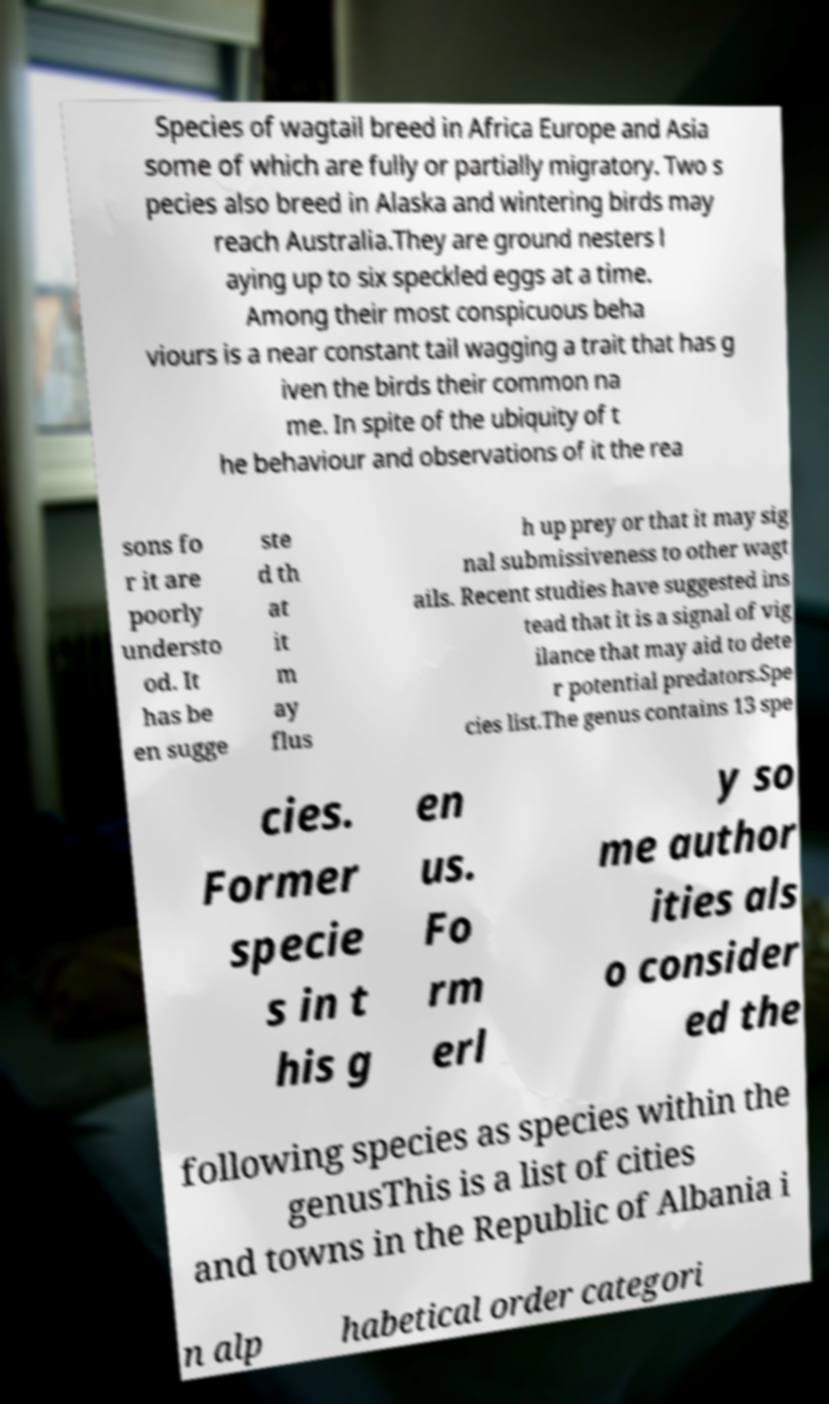Please read and relay the text visible in this image. What does it say? Species of wagtail breed in Africa Europe and Asia some of which are fully or partially migratory. Two s pecies also breed in Alaska and wintering birds may reach Australia.They are ground nesters l aying up to six speckled eggs at a time. Among their most conspicuous beha viours is a near constant tail wagging a trait that has g iven the birds their common na me. In spite of the ubiquity of t he behaviour and observations of it the rea sons fo r it are poorly understo od. It has be en sugge ste d th at it m ay flus h up prey or that it may sig nal submissiveness to other wagt ails. Recent studies have suggested ins tead that it is a signal of vig ilance that may aid to dete r potential predators.Spe cies list.The genus contains 13 spe cies. Former specie s in t his g en us. Fo rm erl y so me author ities als o consider ed the following species as species within the genusThis is a list of cities and towns in the Republic of Albania i n alp habetical order categori 